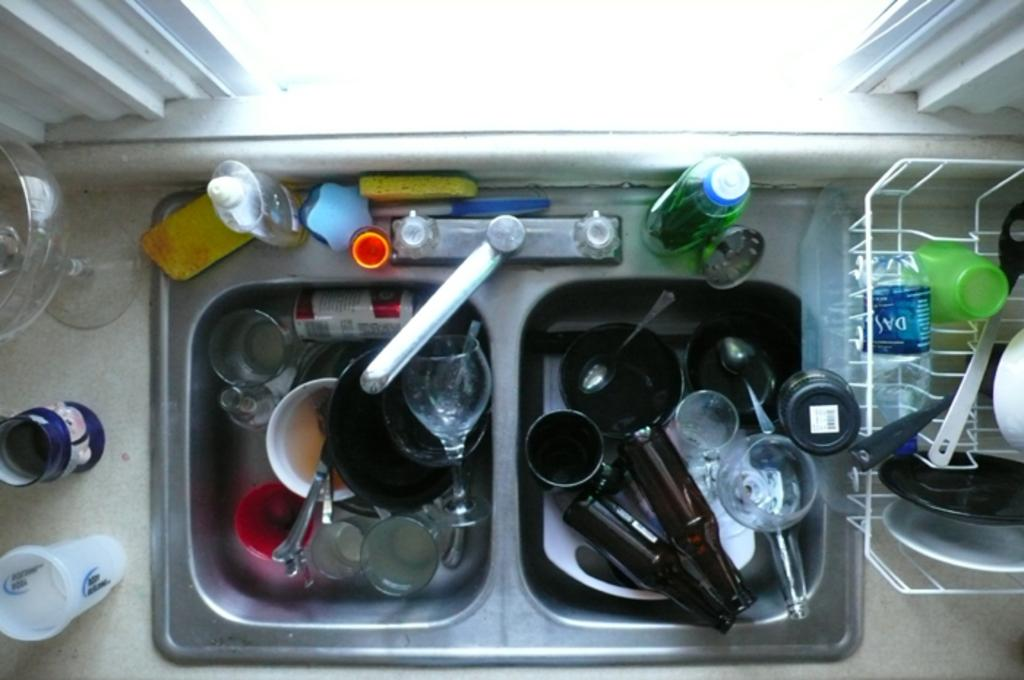What types of items can be seen in the image? There are dishes, bottles, glasses, and dish wash bottles in the image. Where are these items located? The items are in a sink in the image. What is used for cleaning the items in the image? Dish wash bottles are used for cleaning the items in the image. What is the source of water in the image? There is a tap in the image that provides water. What can be seen outside the window in the image? The facts provided do not mention anything about the window's view. What word is written on the furniture in the image? There is no furniture present in the image, and therefore no word can be seen written on it. 